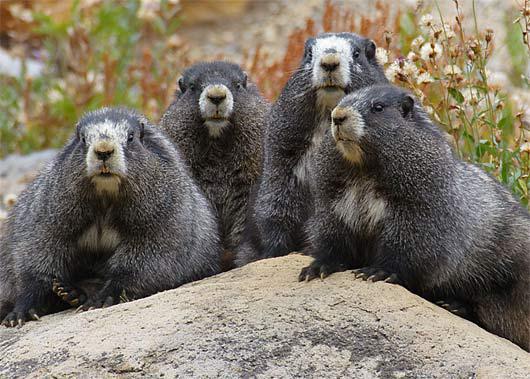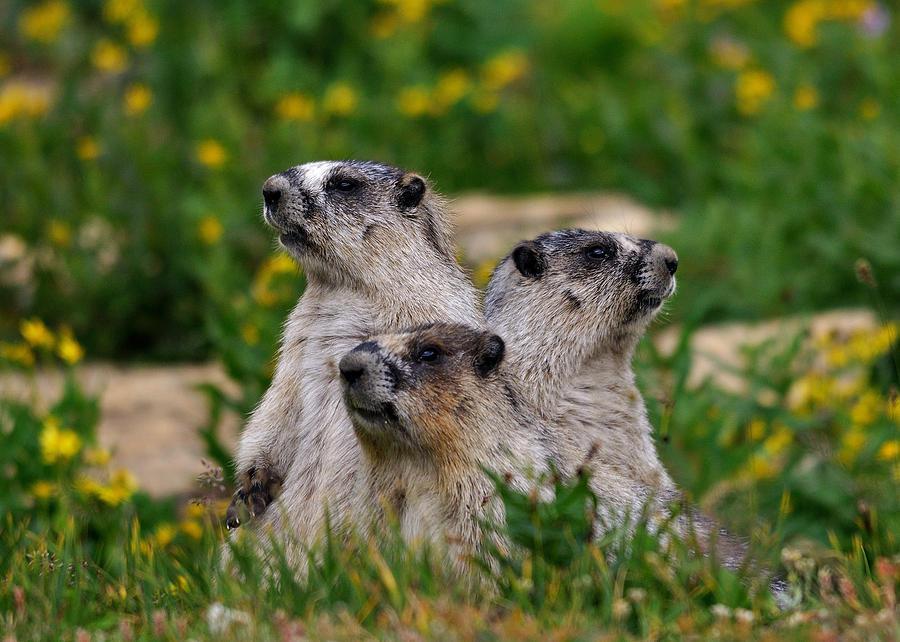The first image is the image on the left, the second image is the image on the right. For the images shown, is this caption "Each image contains at least three marmots in a close grouping." true? Answer yes or no. Yes. 